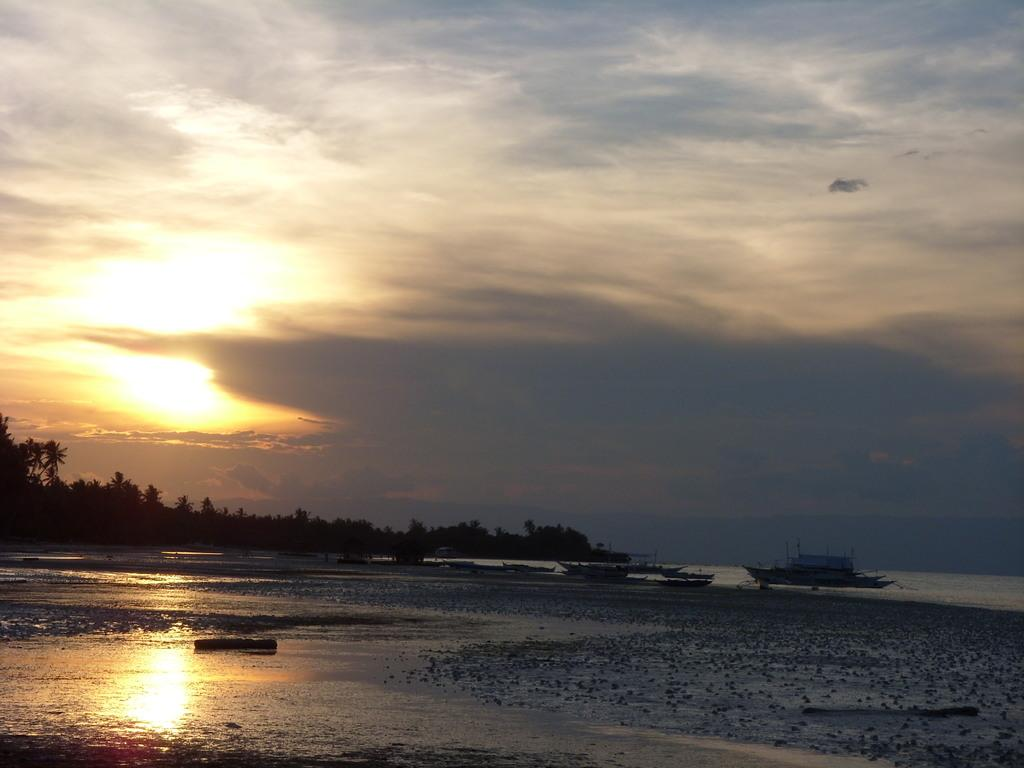Where was the image taken? The image was taken at a sea shore. What can be seen on the shore in the image? There are boats on the shore in the image. What type of vegetation is visible towards the left side of the image? There are trees towards the left side of the image. What is visible in the background of the image? The sky is visible in the image, and clouds are present in the sky. How many geese are standing on the spot where the boats are located in the image? There are no geese present in the image; it features a sea shore with boats and trees. 